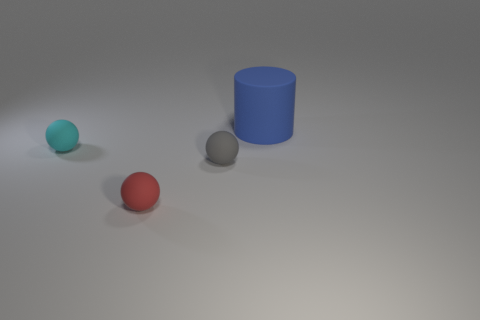How big is the rubber object that is right of the tiny ball right of the tiny sphere in front of the small gray rubber object? The question seems to be based on a misinterpretation of the scene. There are three objects: a small teal sphere, a small red sphere, and a larger blue cylinder. The blue cylinder could be described as the object to the right of the small red sphere, and it is larger compared to the spheres. 